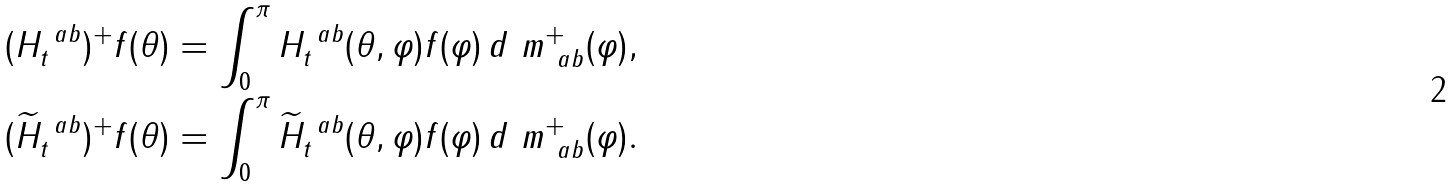Convert formula to latex. <formula><loc_0><loc_0><loc_500><loc_500>( H _ { t } ^ { \ a b } ) ^ { + } f ( \theta ) & = \int _ { 0 } ^ { \pi } H _ { t } ^ { \ a b } ( \theta , \varphi ) f ( \varphi ) \, d \ m _ { \ a b } ^ { + } ( \varphi ) , \\ ( \widetilde { H } _ { t } ^ { \ a b } ) ^ { + } f ( \theta ) & = \int _ { 0 } ^ { \pi } \widetilde { H } _ { t } ^ { \ a b } ( \theta , \varphi ) f ( \varphi ) \, d \ m _ { \ a b } ^ { + } ( \varphi ) .</formula> 